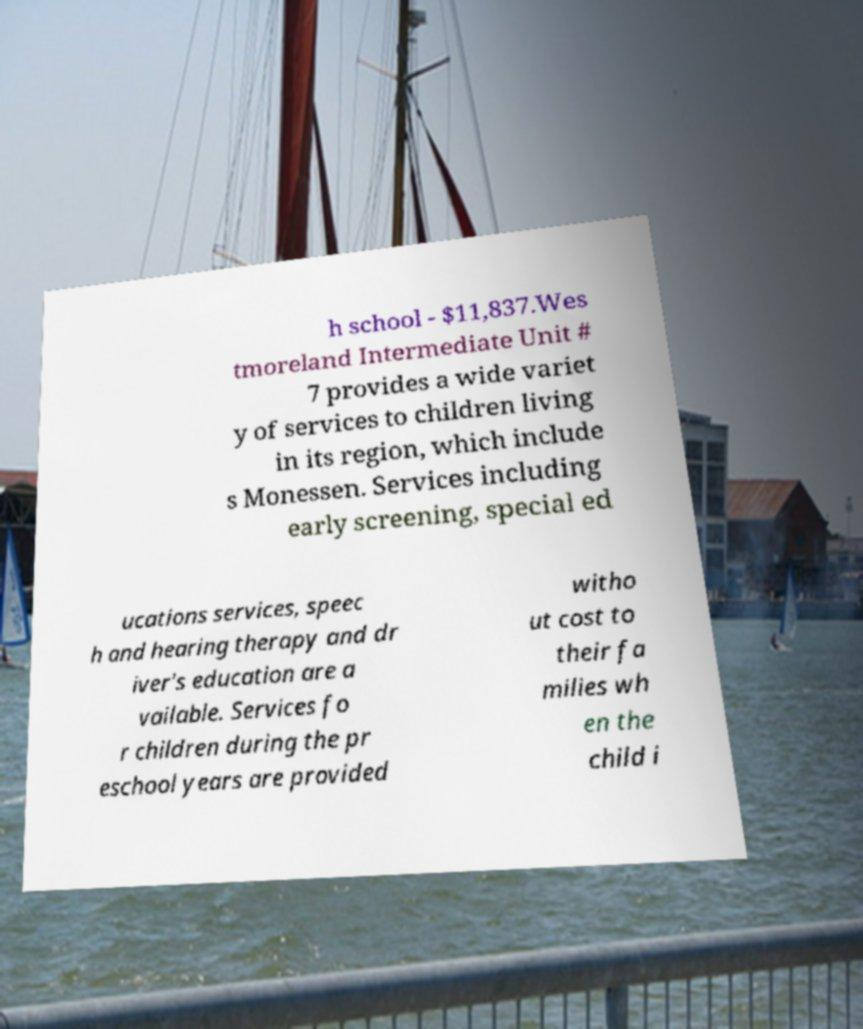Could you assist in decoding the text presented in this image and type it out clearly? h school - $11,837.Wes tmoreland Intermediate Unit # 7 provides a wide variet y of services to children living in its region, which include s Monessen. Services including early screening, special ed ucations services, speec h and hearing therapy and dr iver's education are a vailable. Services fo r children during the pr eschool years are provided witho ut cost to their fa milies wh en the child i 